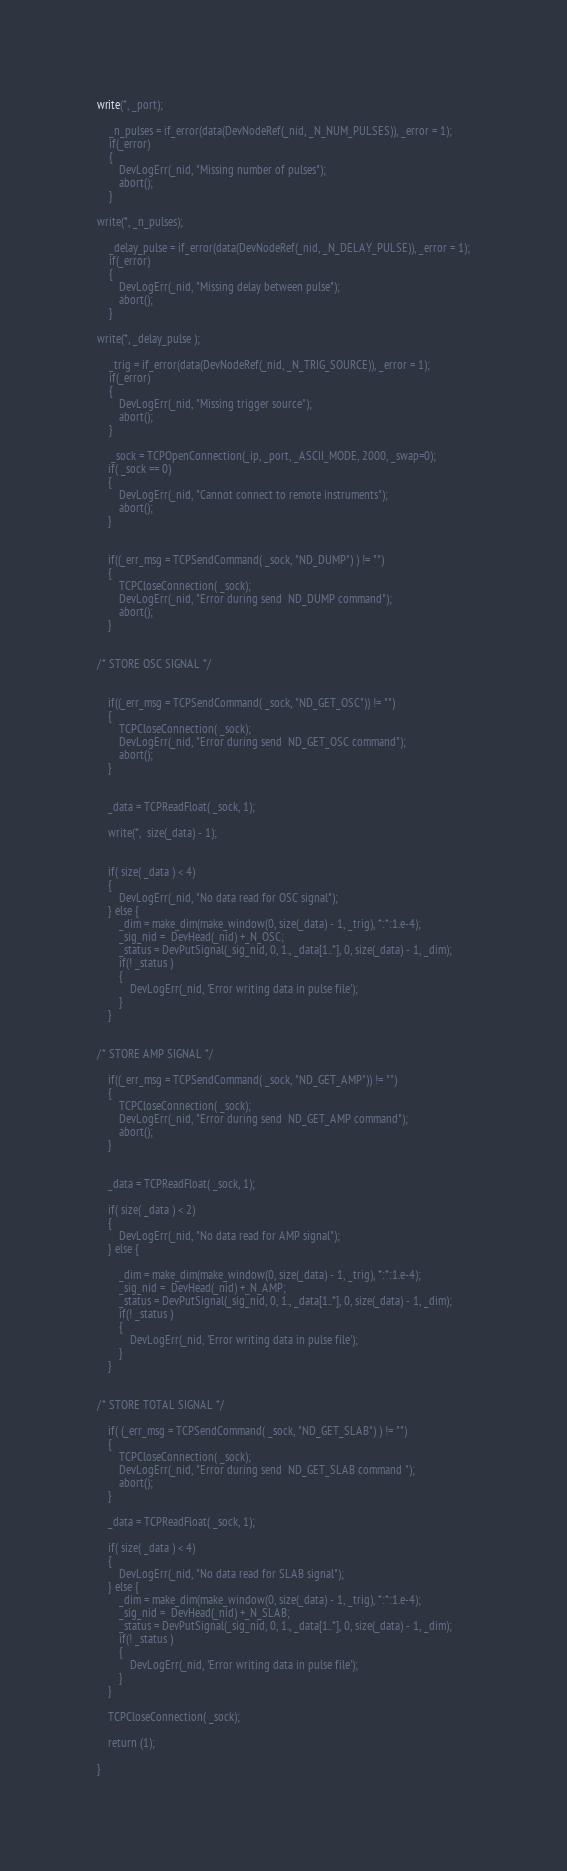Convert code to text. <code><loc_0><loc_0><loc_500><loc_500><_SML_>write(*, _port);

    _n_pulses = if_error(data(DevNodeRef(_nid, _N_NUM_PULSES)), _error = 1);
    if(_error)
    {
		DevLogErr(_nid, "Missing number of pulses");
		abort();
    }

write(*, _n_pulses);

    _delay_pulse = if_error(data(DevNodeRef(_nid, _N_DELAY_PULSE)), _error = 1);
    if(_error)
    {
		DevLogErr(_nid, "Missing delay between pulse");
		abort();
    }

write(*, _delay_pulse );

    _trig = if_error(data(DevNodeRef(_nid, _N_TRIG_SOURCE)), _error = 1);
    if(_error)
    {
		DevLogErr(_nid, "Missing trigger source");
		abort();
    }

	 _sock = TCPOpenConnection(_ip, _port, _ASCII_MODE, 2000, _swap=0);
	if( _sock == 0)
	{
		DevLogErr(_nid, "Cannot connect to remote instruments"); 
		abort();
	}


	if((_err_msg = TCPSendCommand( _sock, "ND_DUMP") ) != "")
	{
		TCPCloseConnection( _sock);
		DevLogErr(_nid, "Error during send  ND_DUMP command"); 
		abort();
	}


/* STORE OSC SIGNAL */


	if((_err_msg = TCPSendCommand( _sock, "ND_GET_OSC")) != "")
	{
		TCPCloseConnection( _sock);
		DevLogErr(_nid, "Error during send  ND_GET_OSC command"); 
		abort();
	}


	_data = TCPReadFloat( _sock, 1);

	write(*,  size(_data) - 1);


	if( size( _data ) < 4)
	{
		DevLogErr(_nid, "No data read for OSC signal"); 
	} else {
		_dim = make_dim(make_window(0, size(_data) - 1, _trig), *:*:1.e-4);
		_sig_nid =  DevHead(_nid) +_N_OSC;
		_status = DevPutSignal(_sig_nid, 0, 1., _data[1..*], 0, size(_data) - 1, _dim);
		if(! _status )
		{
			DevLogErr(_nid, 'Error writing data in pulse file');
		}
	}


/* STORE AMP SIGNAL */

	if((_err_msg = TCPSendCommand( _sock, "ND_GET_AMP")) != "")
	{
		TCPCloseConnection( _sock);
		DevLogErr(_nid, "Error during send  ND_GET_AMP command"); 
		abort();
	}


	_data = TCPReadFloat( _sock, 1);

	if( size( _data ) < 2)
	{
		DevLogErr(_nid, "No data read for AMP signal"); 
	} else {

		_dim = make_dim(make_window(0, size(_data) - 1, _trig), *:*:1.e-4);
		_sig_nid =  DevHead(_nid) +_N_AMP;
		_status = DevPutSignal(_sig_nid, 0, 1., _data[1..*], 0, size(_data) - 1, _dim);
		if(! _status )
		{
			DevLogErr(_nid, 'Error writing data in pulse file');
		}	
	}


/* STORE TOTAL SIGNAL */

	if( (_err_msg = TCPSendCommand( _sock, "ND_GET_SLAB") ) != "")
	{
		TCPCloseConnection( _sock);
		DevLogErr(_nid, "Error during send  ND_GET_SLAB command "); 
		abort();
	}

	_data = TCPReadFloat( _sock, 1);

	if( size( _data ) < 4)
	{
		DevLogErr(_nid, "No data read for SLAB signal"); 
	} else {
		_dim = make_dim(make_window(0, size(_data) - 1, _trig), *:*:1.e-4);
		_sig_nid =  DevHead(_nid) +_N_SLAB;
		_status = DevPutSignal(_sig_nid, 0, 1., _data[1..*], 0, size(_data) - 1, _dim);
		if(! _status )
		{
			DevLogErr(_nid, 'Error writing data in pulse file');
		}
	}

	TCPCloseConnection( _sock);

	return (1);

}















</code> 